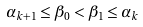<formula> <loc_0><loc_0><loc_500><loc_500>\alpha _ { k + 1 } \leq \beta _ { 0 } < \beta _ { 1 } \leq \alpha _ { k }</formula> 